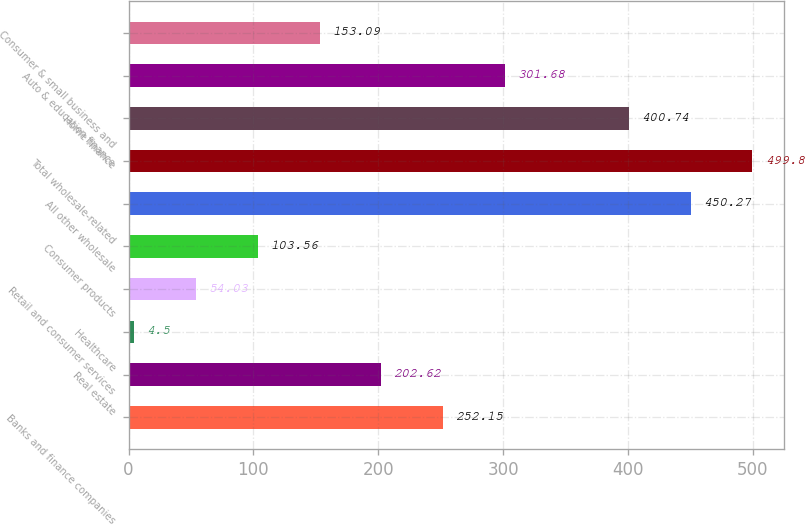Convert chart to OTSL. <chart><loc_0><loc_0><loc_500><loc_500><bar_chart><fcel>Banks and finance companies<fcel>Real estate<fcel>Healthcare<fcel>Retail and consumer services<fcel>Consumer products<fcel>All other wholesale<fcel>Total wholesale-related<fcel>Home finance<fcel>Auto & education finance<fcel>Consumer & small business and<nl><fcel>252.15<fcel>202.62<fcel>4.5<fcel>54.03<fcel>103.56<fcel>450.27<fcel>499.8<fcel>400.74<fcel>301.68<fcel>153.09<nl></chart> 